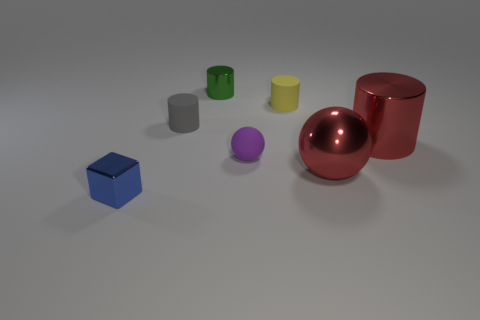Subtract all red cubes. Subtract all green cylinders. How many cubes are left? 1 Add 2 tiny yellow matte cubes. How many objects exist? 9 Subtract all spheres. How many objects are left? 5 Subtract all metallic objects. Subtract all brown metal cylinders. How many objects are left? 3 Add 1 tiny rubber spheres. How many tiny rubber spheres are left? 2 Add 3 cylinders. How many cylinders exist? 7 Subtract 0 blue spheres. How many objects are left? 7 